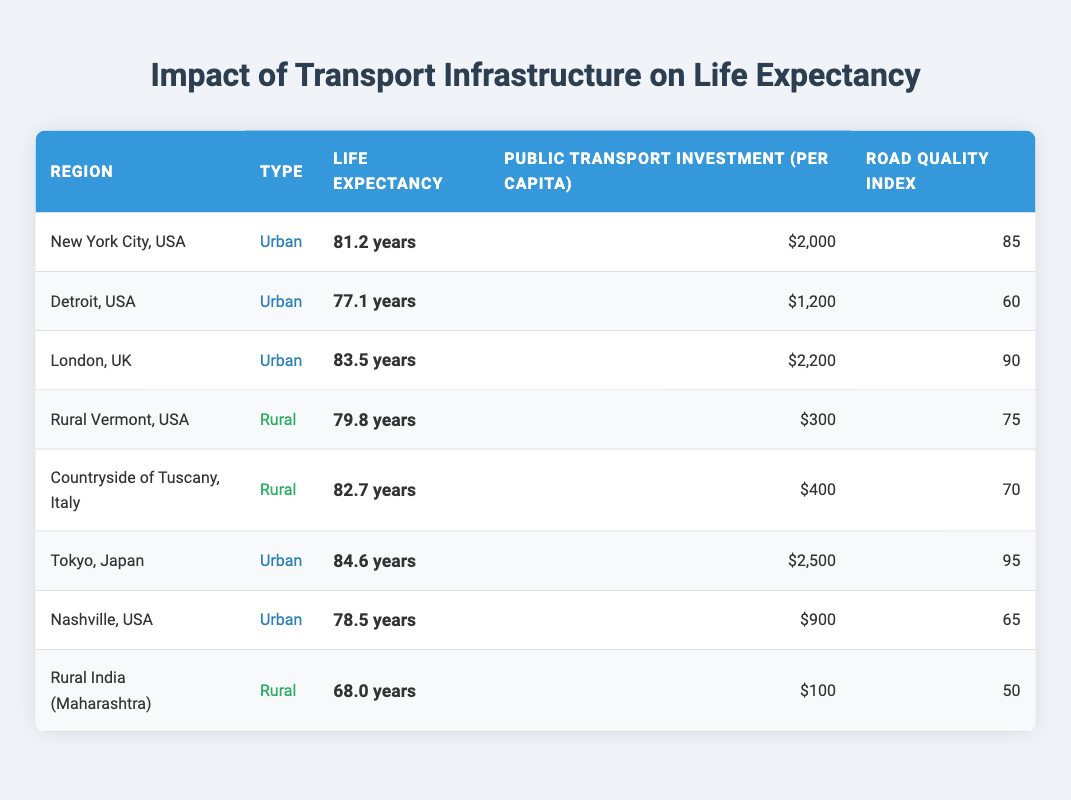What is the life expectancy in Tokyo, Japan? The life expectancy value for Tokyo, Japan is explicitly listed in the table under the "Life Expectancy" column. According to the table, it is 84.6 years.
Answer: 84.6 years Which urban region has the lowest life expectancy? To find the urban region with the lowest life expectancy, we compare the life expectancy values for the urban regions: New York City (81.2), Detroit (77.1), London (83.5), and Nashville (78.5). The lowest among these is Detroit, which has a life expectancy of 77.1 years.
Answer: Detroit, USA What is the average life expectancy for rural regions? To calculate the average life expectancy for rural regions, we first identify the life expectancy values for the rural areas: Rural Vermont (79.8), Countryside of Tuscany (82.7), and Rural India (68.0). We sum these values (79.8 + 82.7 + 68.0 = 230.5) and divide by the number of rural regions (3) to get the average: 230.5 / 3 = 76.83 years.
Answer: 76.83 years Is the public transport investment per capita in Nashville greater than that in Tokyo? From the table, we see that the public transport investment per capita in Nashville is $900, while in Tokyo it is $2,500. Since $900 is less than $2,500, the statement is false.
Answer: No What is the difference in life expectancy between the highest and lowest rural regions? The highest life expectancy among the rural regions is from the Countryside of Tuscany at 82.7 years, and the lowest is from Rural India at 68.0 years. The difference is calculated as: 82.7 - 68.0 = 14.7 years.
Answer: 14.7 years 